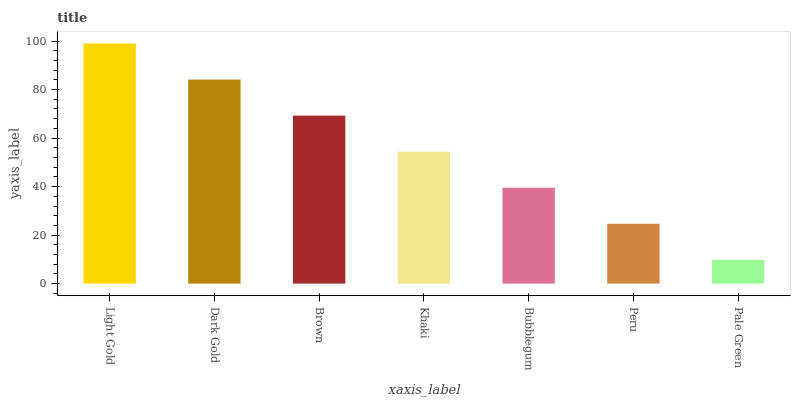Is Pale Green the minimum?
Answer yes or no. Yes. Is Light Gold the maximum?
Answer yes or no. Yes. Is Dark Gold the minimum?
Answer yes or no. No. Is Dark Gold the maximum?
Answer yes or no. No. Is Light Gold greater than Dark Gold?
Answer yes or no. Yes. Is Dark Gold less than Light Gold?
Answer yes or no. Yes. Is Dark Gold greater than Light Gold?
Answer yes or no. No. Is Light Gold less than Dark Gold?
Answer yes or no. No. Is Khaki the high median?
Answer yes or no. Yes. Is Khaki the low median?
Answer yes or no. Yes. Is Bubblegum the high median?
Answer yes or no. No. Is Light Gold the low median?
Answer yes or no. No. 